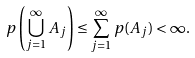<formula> <loc_0><loc_0><loc_500><loc_500>p \left ( \bigcup _ { j = 1 } ^ { \infty } A _ { j } \right ) \leq \sum _ { j = 1 } ^ { \infty } p ( A _ { j } ) < \infty .</formula> 